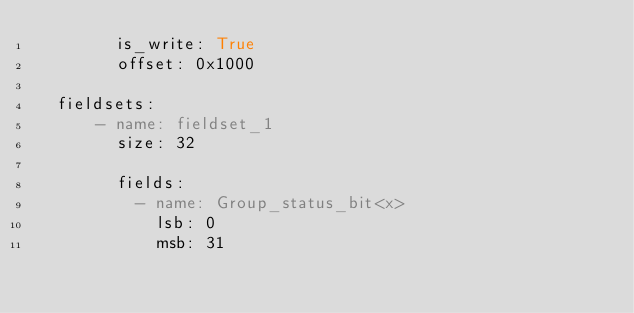<code> <loc_0><loc_0><loc_500><loc_500><_YAML_>        is_write: True
        offset: 0x1000

  fieldsets:
      - name: fieldset_1
        size: 32

        fields:
          - name: Group_status_bit<x>
            lsb: 0
            msb: 31
</code> 